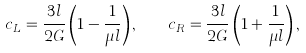Convert formula to latex. <formula><loc_0><loc_0><loc_500><loc_500>c _ { L } = \frac { 3 l } { 2 G } \left ( 1 - \frac { 1 } { \mu l } \right ) , \quad c _ { R } = \frac { 3 l } { 2 G } \left ( 1 + \frac { 1 } { \mu l } \right ) ,</formula> 